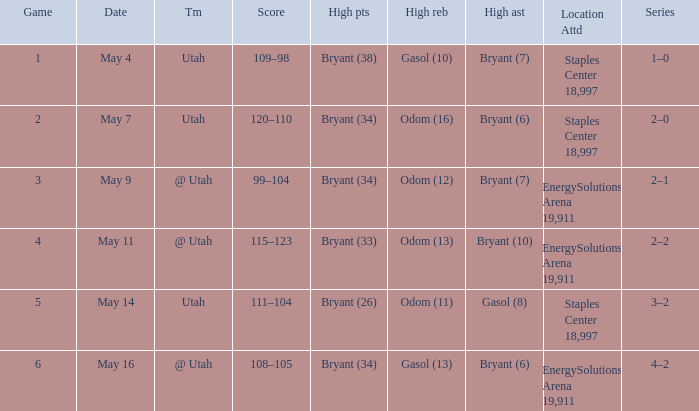What is the High rebounds with a High assists with bryant (7), and a Team of @ utah? Odom (12). 